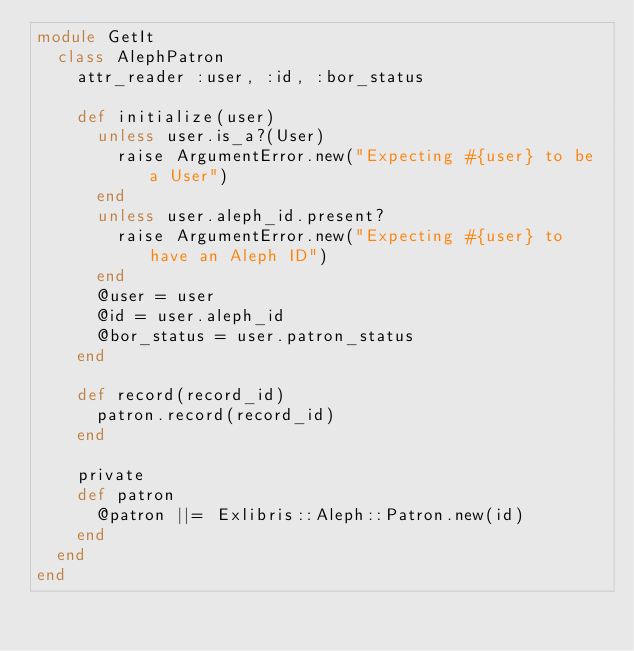Convert code to text. <code><loc_0><loc_0><loc_500><loc_500><_Ruby_>module GetIt
  class AlephPatron
    attr_reader :user, :id, :bor_status

    def initialize(user)
      unless user.is_a?(User)
        raise ArgumentError.new("Expecting #{user} to be a User")
      end
      unless user.aleph_id.present?
        raise ArgumentError.new("Expecting #{user} to have an Aleph ID")
      end
      @user = user
      @id = user.aleph_id
      @bor_status = user.patron_status
    end

    def record(record_id)
      patron.record(record_id)
    end

    private
    def patron
      @patron ||= Exlibris::Aleph::Patron.new(id)
    end
  end
end
</code> 